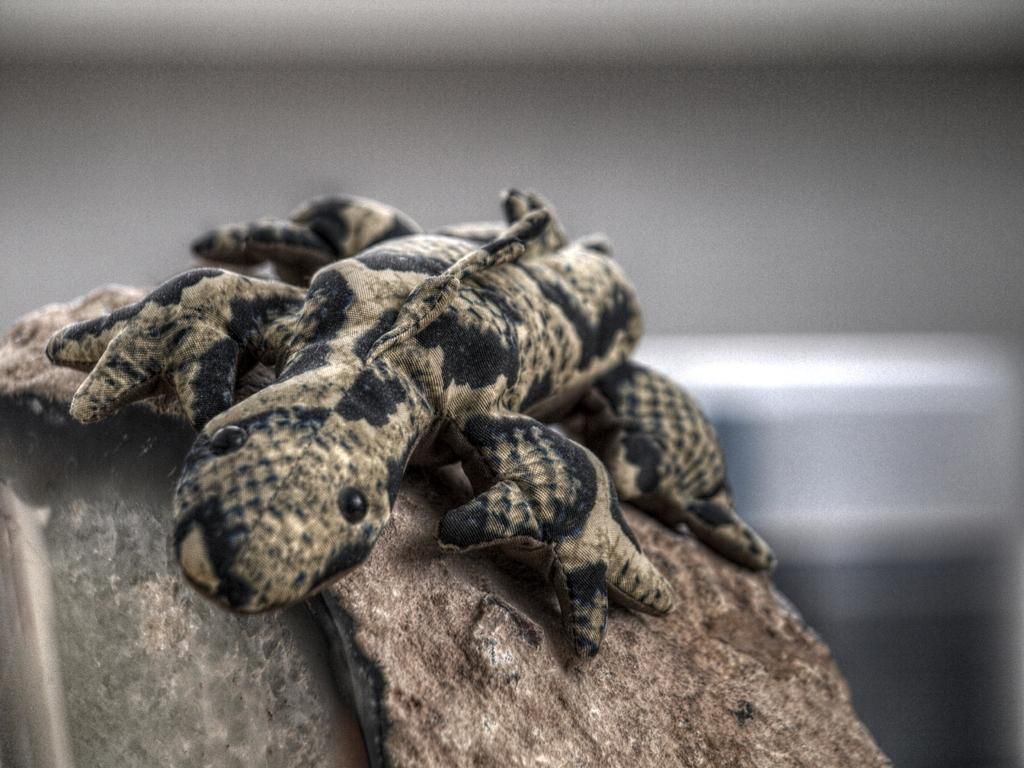What type of animal is in the image? There is a lizard in the image. Where is the lizard located? The lizard is on a rock. Can you describe the background of the image? The background of the image is blurred. What type of crowd can be seen during the recess in the image? There is no crowd or recess present in the image; it features a lizard on a rock with a blurred background. What is the kettle used for in the image? There is no kettle present in the image. 